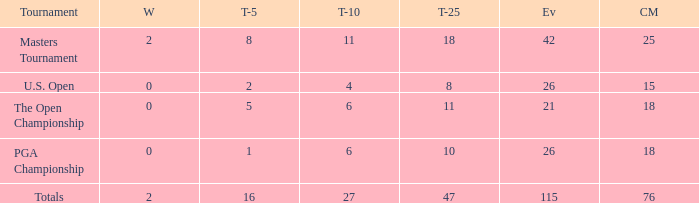How many wins are there in total when 76 cuts are made and more than 115 events occur? None. 